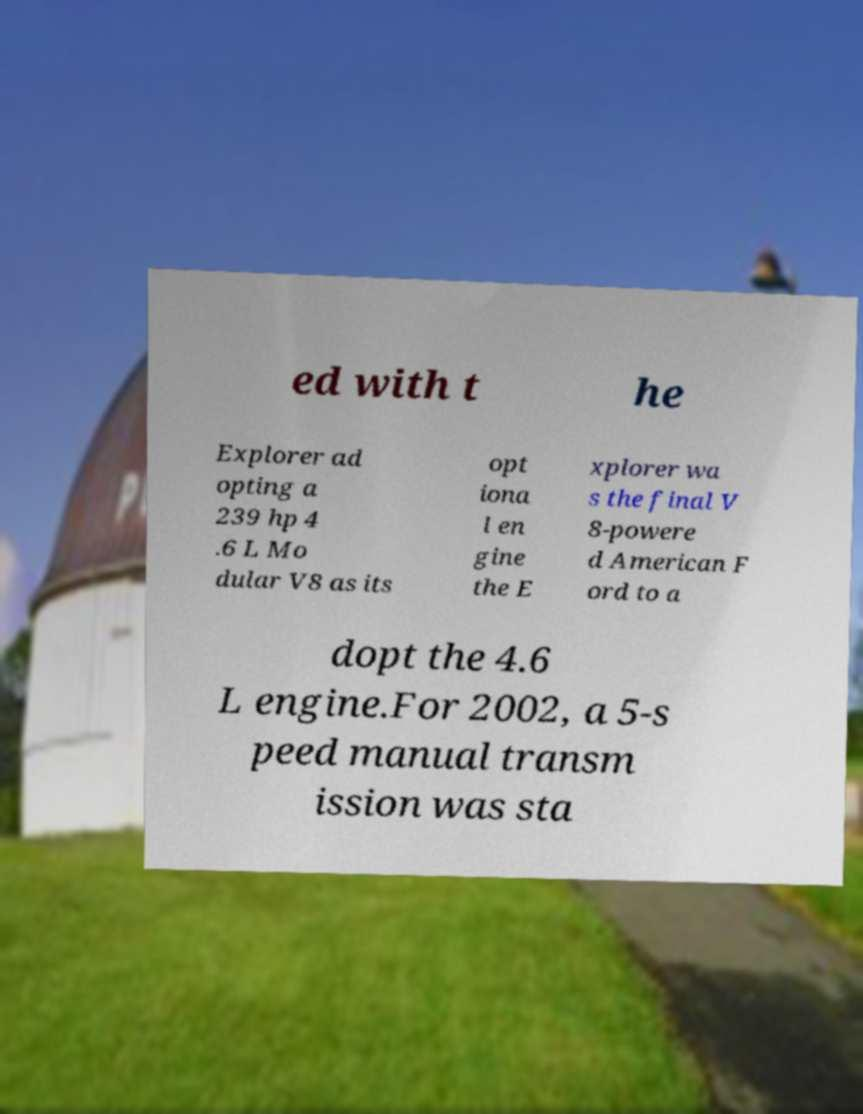Could you assist in decoding the text presented in this image and type it out clearly? ed with t he Explorer ad opting a 239 hp 4 .6 L Mo dular V8 as its opt iona l en gine the E xplorer wa s the final V 8-powere d American F ord to a dopt the 4.6 L engine.For 2002, a 5-s peed manual transm ission was sta 